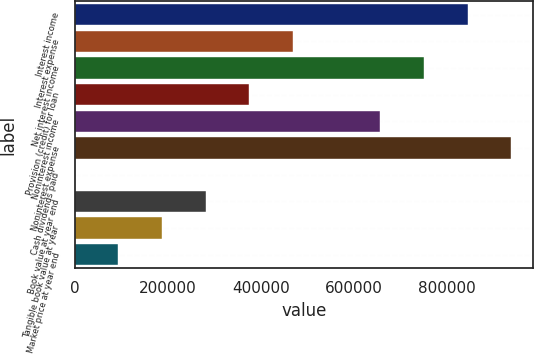<chart> <loc_0><loc_0><loc_500><loc_500><bar_chart><fcel>Interest income<fcel>Interest expense<fcel>Net interest income<fcel>Provision (credit) for loan<fcel>Noninterest income<fcel>Noninterest expense<fcel>Cash dividends paid<fcel>Book value at year end<fcel>Tangible book value at year<fcel>Market price at year end<nl><fcel>845047<fcel>469471<fcel>751153<fcel>375576<fcel>657259<fcel>938941<fcel>0.18<fcel>281682<fcel>187788<fcel>93894.3<nl></chart> 